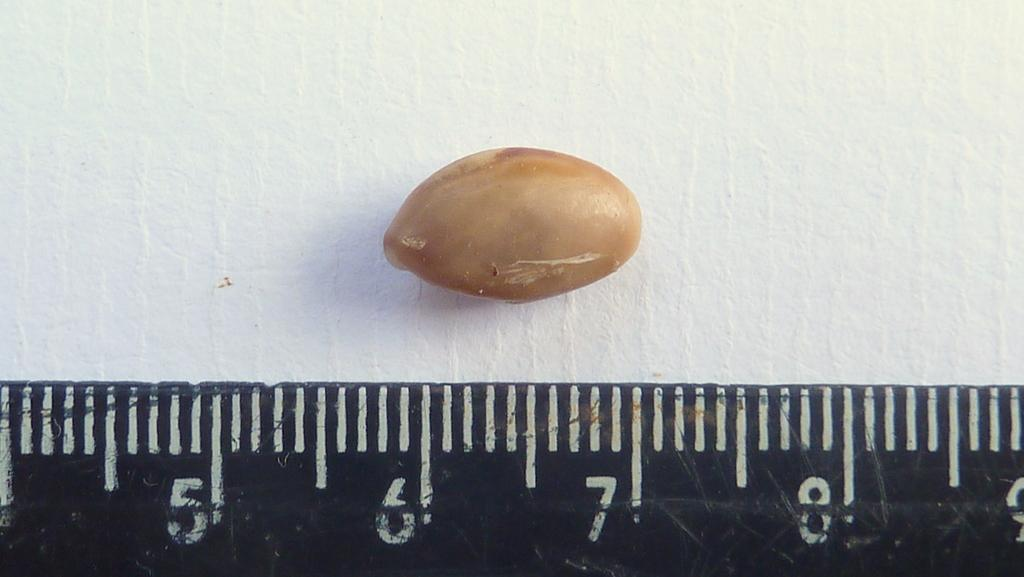<image>
Create a compact narrative representing the image presented. A nut is being measured against  a black ruler between 6 and 7 